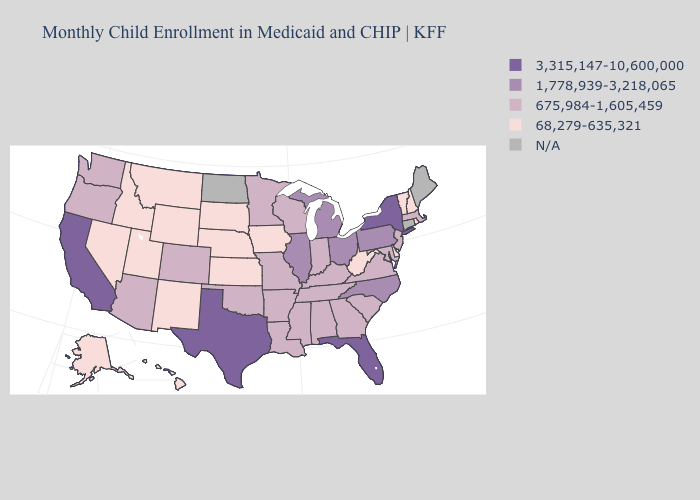Which states have the lowest value in the West?
Concise answer only. Alaska, Hawaii, Idaho, Montana, Nevada, New Mexico, Utah, Wyoming. Does Kansas have the highest value in the USA?
Answer briefly. No. What is the value of Missouri?
Answer briefly. 675,984-1,605,459. What is the value of Wisconsin?
Concise answer only. 675,984-1,605,459. What is the value of Maine?
Concise answer only. N/A. Does the map have missing data?
Concise answer only. Yes. Name the states that have a value in the range N/A?
Write a very short answer. Connecticut, Maine, North Dakota. Does the first symbol in the legend represent the smallest category?
Write a very short answer. No. What is the value of Arizona?
Give a very brief answer. 675,984-1,605,459. What is the highest value in states that border California?
Short answer required. 675,984-1,605,459. Name the states that have a value in the range N/A?
Give a very brief answer. Connecticut, Maine, North Dakota. What is the value of Missouri?
Quick response, please. 675,984-1,605,459. Name the states that have a value in the range 675,984-1,605,459?
Quick response, please. Alabama, Arizona, Arkansas, Colorado, Georgia, Indiana, Kentucky, Louisiana, Maryland, Massachusetts, Minnesota, Mississippi, Missouri, New Jersey, Oklahoma, Oregon, South Carolina, Tennessee, Virginia, Washington, Wisconsin. Does the map have missing data?
Be succinct. Yes. 